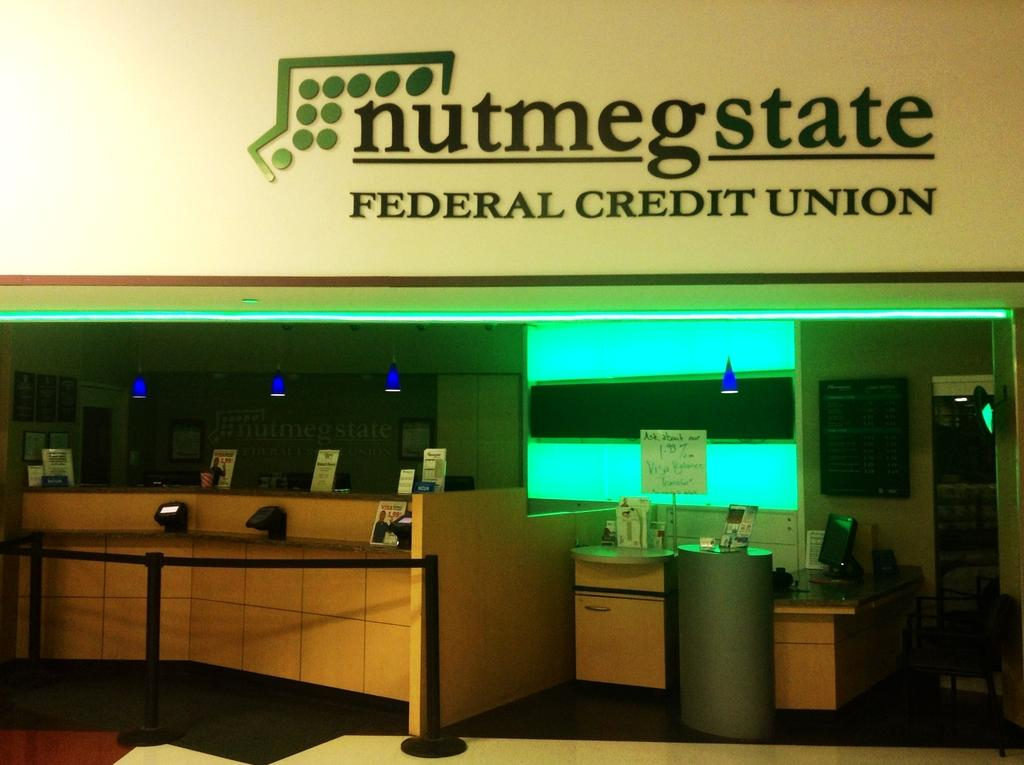What type of objects can be seen in the image? There are boards, stanchions, a monitor, objects on tables, a chair, lights, and a television in the image. What is attached to the wall in the image? There are frames attached to the wall in the image. Can you describe the furniture in the image? There is a chair in the image. What type of lighting is present in the image? There are lights in the image. What type of milk is being served in the image? There is no milk present in the image. Can you describe the fog in the image? There is no fog present in the image. 